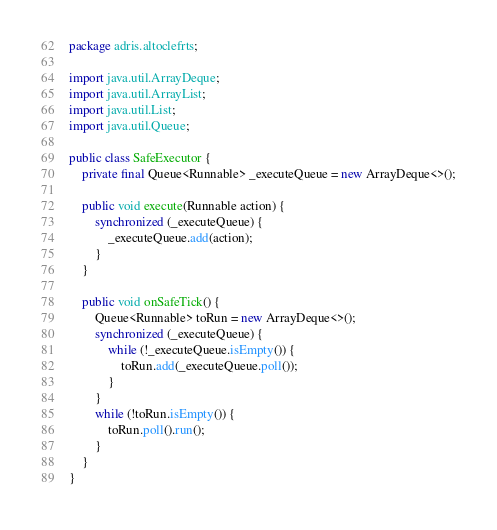<code> <loc_0><loc_0><loc_500><loc_500><_Java_>package adris.altoclefrts;

import java.util.ArrayDeque;
import java.util.ArrayList;
import java.util.List;
import java.util.Queue;

public class SafeExecutor {
    private final Queue<Runnable> _executeQueue = new ArrayDeque<>();

    public void execute(Runnable action) {
        synchronized (_executeQueue) {
            _executeQueue.add(action);
        }
    }

    public void onSafeTick() {
        Queue<Runnable> toRun = new ArrayDeque<>();
        synchronized (_executeQueue) {
            while (!_executeQueue.isEmpty()) {
                toRun.add(_executeQueue.poll());
            }
        }
        while (!toRun.isEmpty()) {
            toRun.poll().run();
        }
    }
}
</code> 